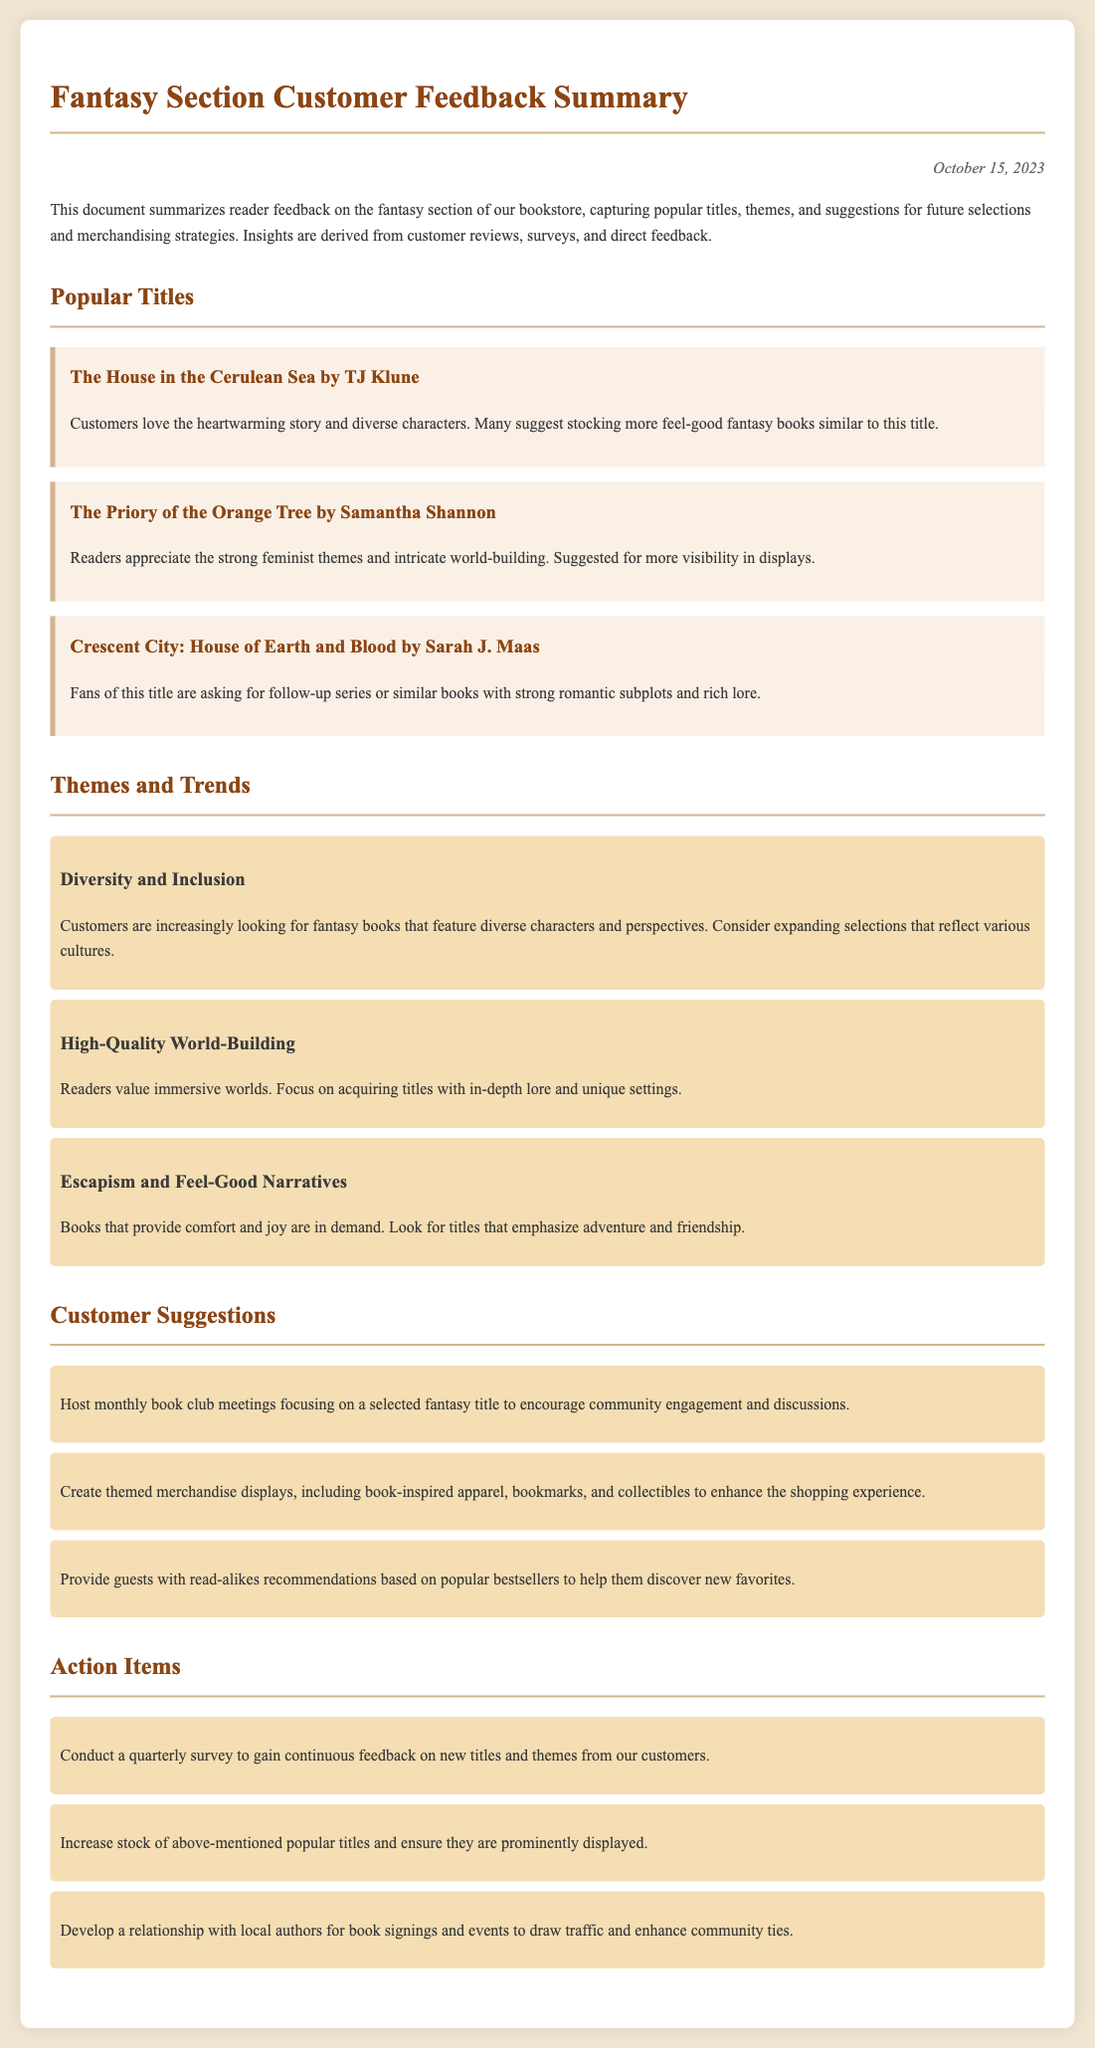What is the date of the feedback summary? The date is provided at the top of the document, indicating when the summary was compiled.
Answer: October 15, 2023 How many popular titles are listed in the document? The document details several popular titles in the fantasy section, each outlined in its own section.
Answer: Three What theme is highlighted regarding character representation? The document discusses customer preferences regarding inclusivity and character diversity in fantasy literature.
Answer: Diversity and Inclusion Which book is recommended for stocking more similar titles? The popular titles section specifies which book readers are asking for more of or similar titles to.
Answer: The House in the Cerulean Sea What action item suggests improving customer engagement? The action items section includes suggestions aimed at enhancing interactions and connections with customers.
Answer: Conduct a quarterly survey What is one suggested merchandise strategy mentioned in the feedback? The customer suggestions section includes ideas for merchandise displays that tie to the books offered.
Answer: Create themed merchandise displays 